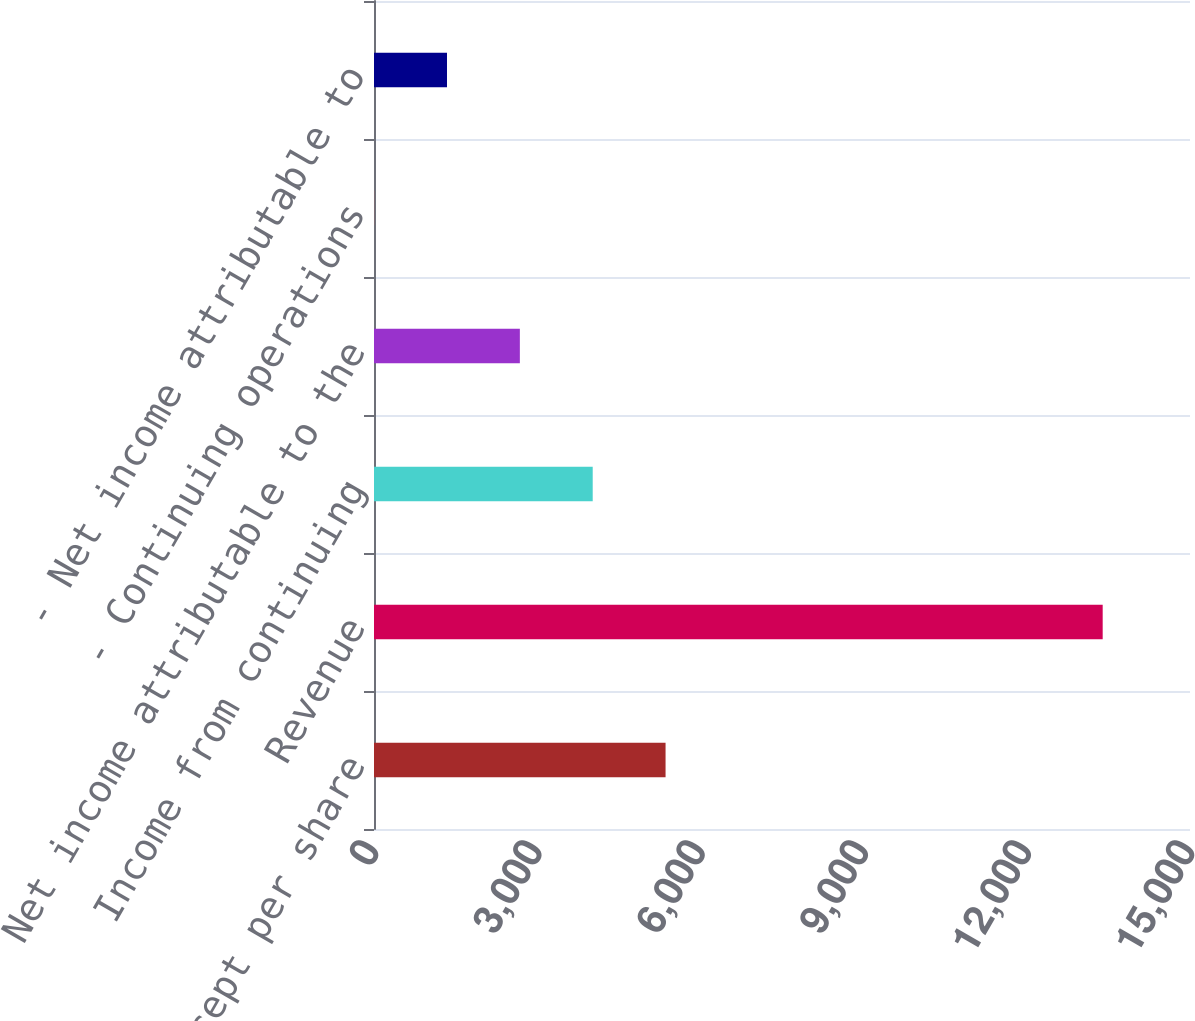Convert chart. <chart><loc_0><loc_0><loc_500><loc_500><bar_chart><fcel>(In millions except per share<fcel>Revenue<fcel>Income from continuing<fcel>Net income attributable to the<fcel>- Continuing operations<fcel>- Net income attributable to<nl><fcel>5359.6<fcel>13395<fcel>4020.36<fcel>2681.12<fcel>2.65<fcel>1341.89<nl></chart> 